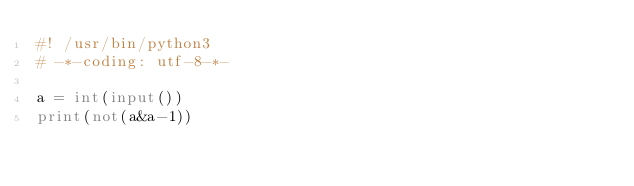<code> <loc_0><loc_0><loc_500><loc_500><_Python_>#! /usr/bin/python3
# -*-coding: utf-8-*-

a = int(input())
print(not(a&a-1))</code> 